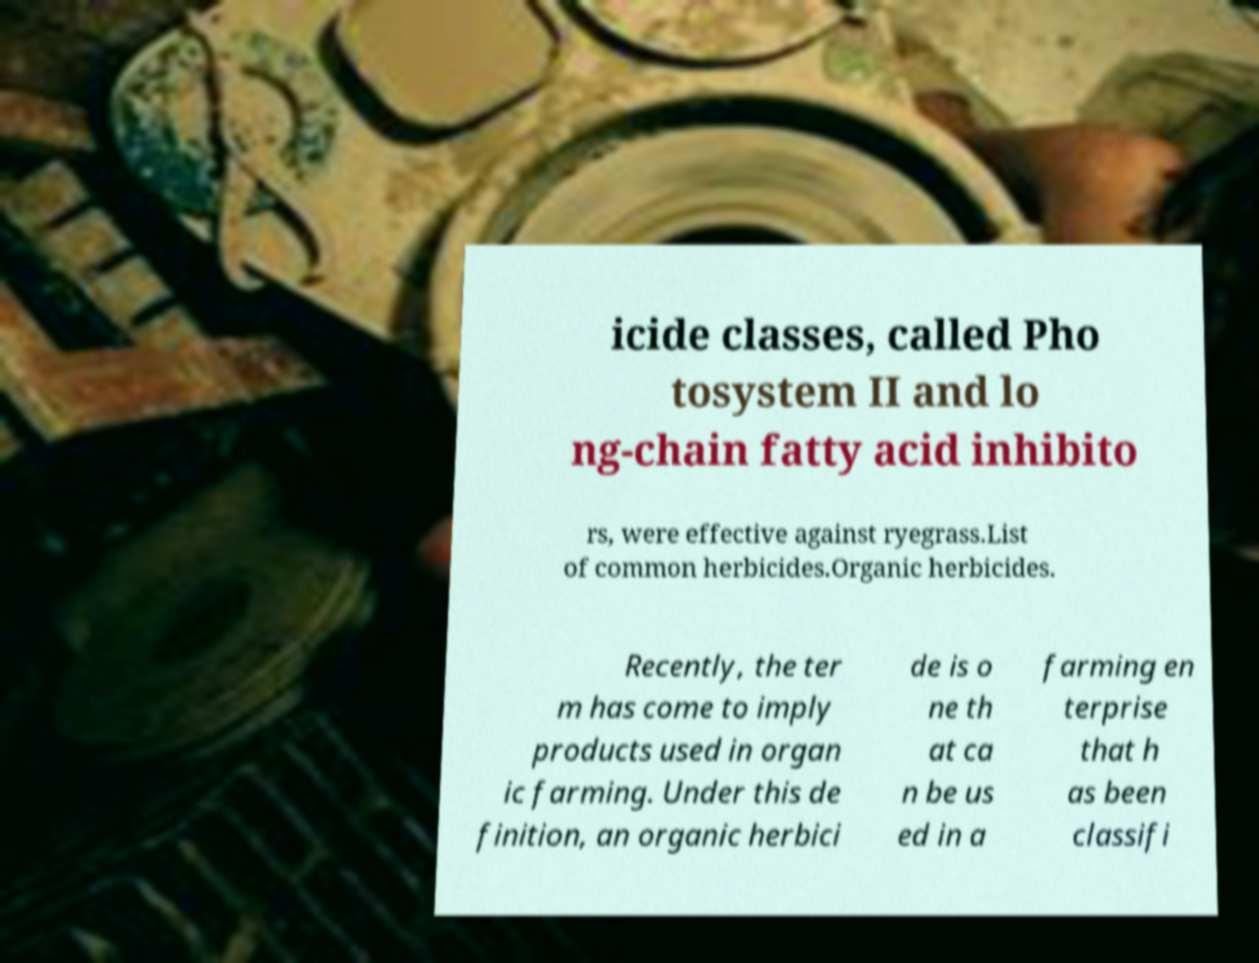There's text embedded in this image that I need extracted. Can you transcribe it verbatim? icide classes, called Pho tosystem II and lo ng-chain fatty acid inhibito rs, were effective against ryegrass.List of common herbicides.Organic herbicides. Recently, the ter m has come to imply products used in organ ic farming. Under this de finition, an organic herbici de is o ne th at ca n be us ed in a farming en terprise that h as been classifi 